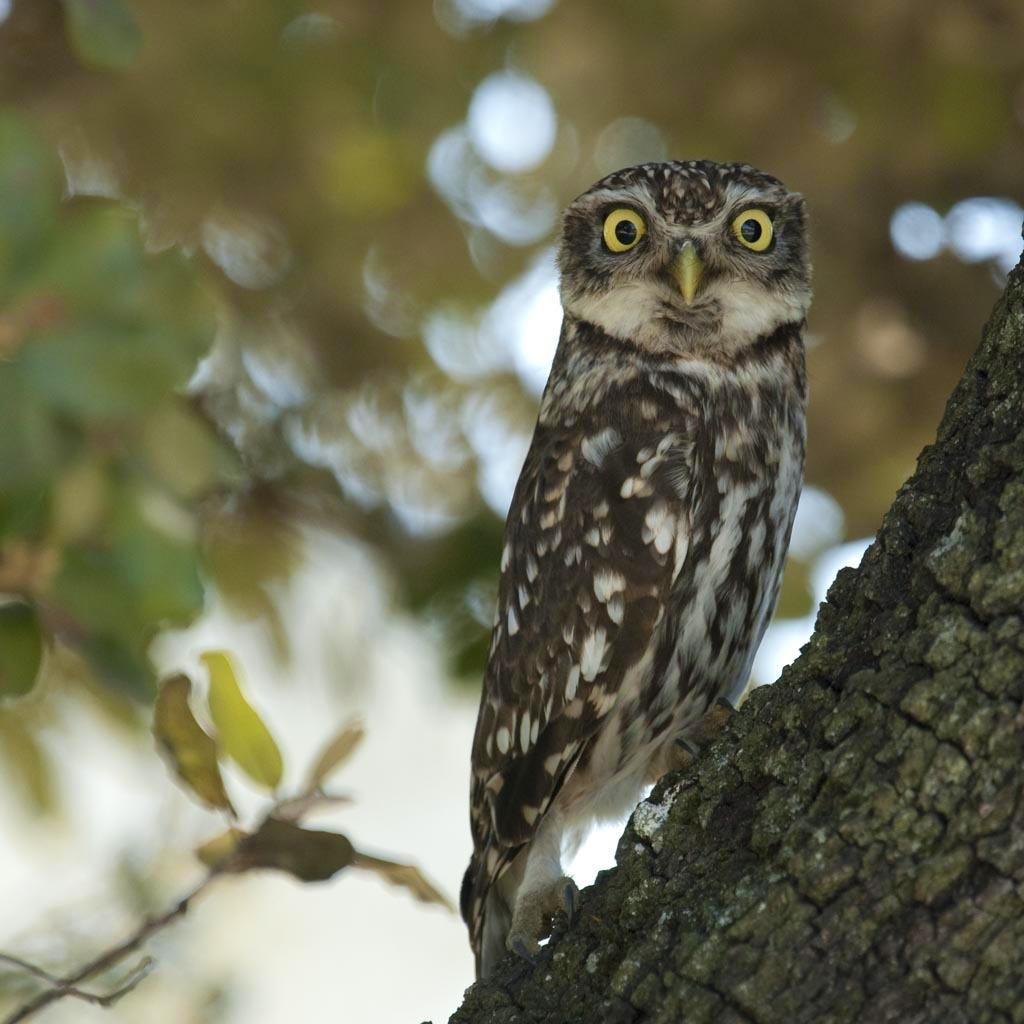What type of animal is in the picture? There is an owl in the picture. Can you describe the coloring of the owl? The owl has brown and white coloring. What color are the owl's eyes? The owl has yellow eyes. Where is the owl sitting in the picture? The owl is sitting on a tree trunk. What is the owl doing in the picture? The owl is looking into the camera. How would you describe the background of the image? The background is blurred in the image. What type of dress is the owl wearing in the picture? Owls do not wear dresses, as they are birds and not human beings. 